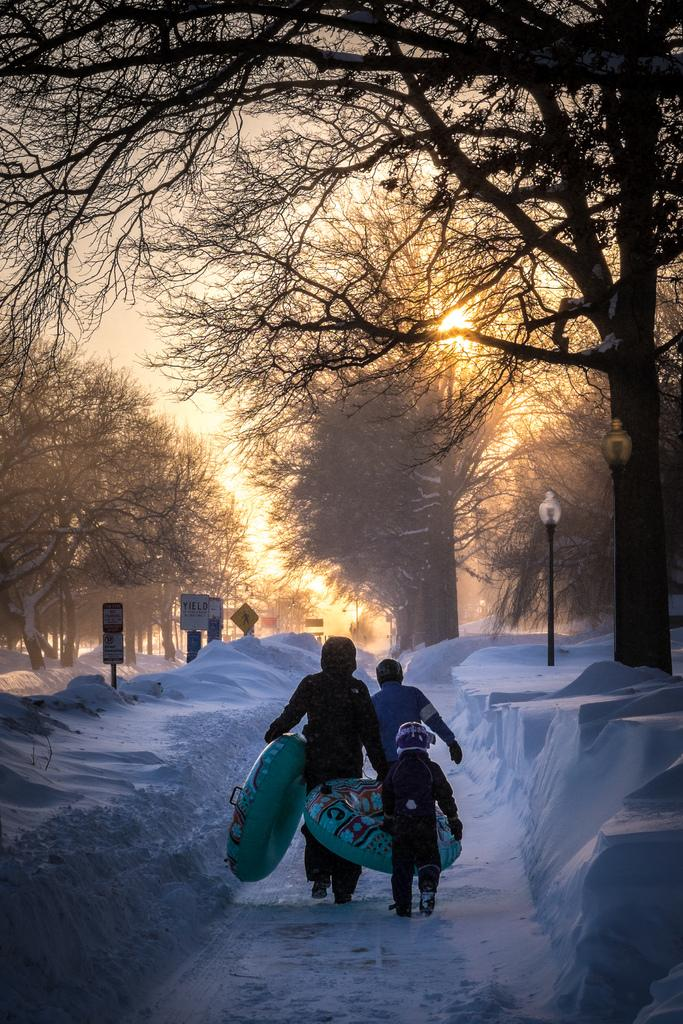How many boys are in the image? There are three boys in the image. What are the boys holding in the image? The boys are holding big balloons in the image. What is the setting of the image? The boys are walking in a snow area in the image. What can be seen in the background of the image? There are many dry trees and a black color lamp post in the background. What type of glove is the boy wearing on his right hand in the image? There is no glove visible on any of the boys' hands in the image. 